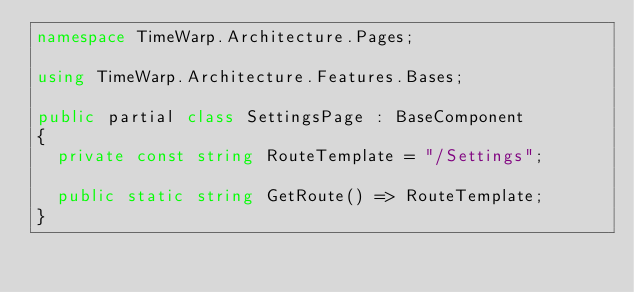<code> <loc_0><loc_0><loc_500><loc_500><_C#_>namespace TimeWarp.Architecture.Pages;

using TimeWarp.Architecture.Features.Bases;

public partial class SettingsPage : BaseComponent
{
  private const string RouteTemplate = "/Settings";

  public static string GetRoute() => RouteTemplate;
}
</code> 